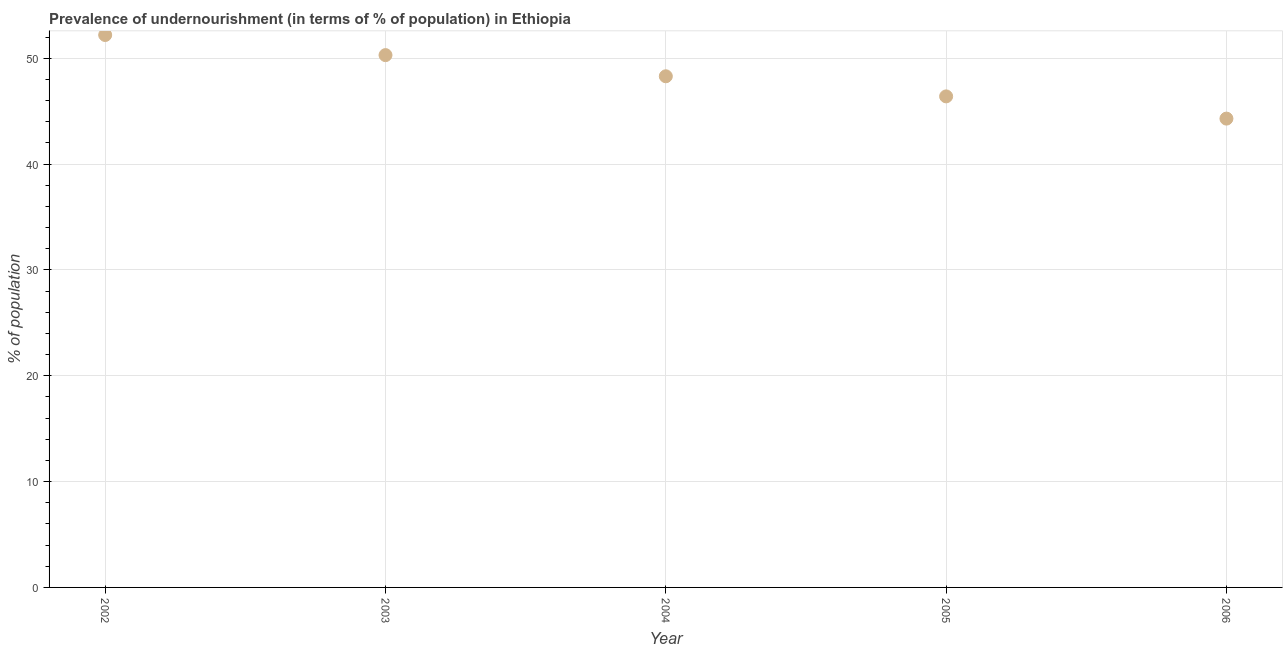What is the percentage of undernourished population in 2004?
Offer a very short reply. 48.3. Across all years, what is the maximum percentage of undernourished population?
Make the answer very short. 52.2. Across all years, what is the minimum percentage of undernourished population?
Provide a succinct answer. 44.3. In which year was the percentage of undernourished population maximum?
Make the answer very short. 2002. What is the sum of the percentage of undernourished population?
Your answer should be very brief. 241.5. What is the difference between the percentage of undernourished population in 2003 and 2006?
Provide a succinct answer. 6. What is the average percentage of undernourished population per year?
Ensure brevity in your answer.  48.3. What is the median percentage of undernourished population?
Keep it short and to the point. 48.3. Do a majority of the years between 2002 and 2005 (inclusive) have percentage of undernourished population greater than 20 %?
Your response must be concise. Yes. What is the ratio of the percentage of undernourished population in 2004 to that in 2005?
Make the answer very short. 1.04. Is the percentage of undernourished population in 2005 less than that in 2006?
Provide a succinct answer. No. Is the difference between the percentage of undernourished population in 2002 and 2005 greater than the difference between any two years?
Offer a terse response. No. What is the difference between the highest and the second highest percentage of undernourished population?
Your answer should be very brief. 1.9. What is the difference between the highest and the lowest percentage of undernourished population?
Your response must be concise. 7.9. In how many years, is the percentage of undernourished population greater than the average percentage of undernourished population taken over all years?
Make the answer very short. 2. How many dotlines are there?
Give a very brief answer. 1. What is the title of the graph?
Keep it short and to the point. Prevalence of undernourishment (in terms of % of population) in Ethiopia. What is the label or title of the Y-axis?
Your answer should be compact. % of population. What is the % of population in 2002?
Make the answer very short. 52.2. What is the % of population in 2003?
Provide a succinct answer. 50.3. What is the % of population in 2004?
Provide a short and direct response. 48.3. What is the % of population in 2005?
Keep it short and to the point. 46.4. What is the % of population in 2006?
Offer a terse response. 44.3. What is the difference between the % of population in 2002 and 2003?
Offer a very short reply. 1.9. What is the difference between the % of population in 2002 and 2004?
Offer a very short reply. 3.9. What is the difference between the % of population in 2002 and 2006?
Ensure brevity in your answer.  7.9. What is the difference between the % of population in 2003 and 2004?
Offer a terse response. 2. What is the difference between the % of population in 2003 and 2005?
Your answer should be very brief. 3.9. What is the difference between the % of population in 2003 and 2006?
Your answer should be very brief. 6. What is the difference between the % of population in 2004 and 2005?
Keep it short and to the point. 1.9. What is the difference between the % of population in 2004 and 2006?
Ensure brevity in your answer.  4. What is the difference between the % of population in 2005 and 2006?
Provide a short and direct response. 2.1. What is the ratio of the % of population in 2002 to that in 2003?
Provide a succinct answer. 1.04. What is the ratio of the % of population in 2002 to that in 2004?
Offer a terse response. 1.08. What is the ratio of the % of population in 2002 to that in 2006?
Your answer should be compact. 1.18. What is the ratio of the % of population in 2003 to that in 2004?
Provide a succinct answer. 1.04. What is the ratio of the % of population in 2003 to that in 2005?
Keep it short and to the point. 1.08. What is the ratio of the % of population in 2003 to that in 2006?
Provide a succinct answer. 1.14. What is the ratio of the % of population in 2004 to that in 2005?
Offer a terse response. 1.04. What is the ratio of the % of population in 2004 to that in 2006?
Keep it short and to the point. 1.09. What is the ratio of the % of population in 2005 to that in 2006?
Your response must be concise. 1.05. 